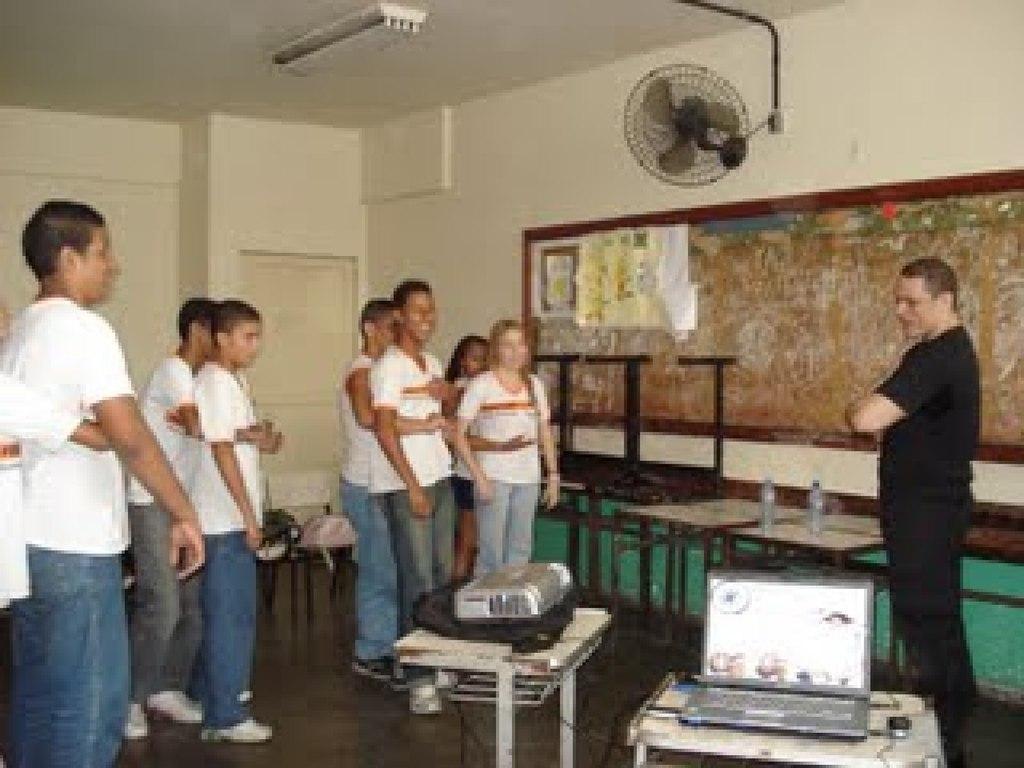Describe this image in one or two sentences. There is a room. There is a group of people. They are standing. They are smiling. There is a table. There is a laptop,bag on a table. We can see in background poster,wall,board and roof. 